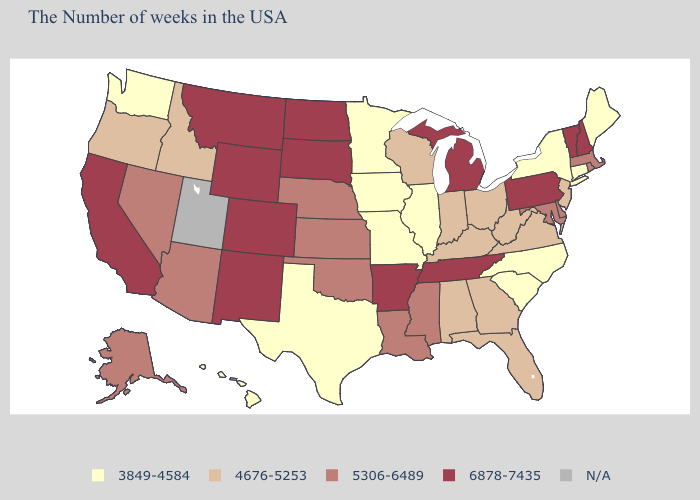How many symbols are there in the legend?
Concise answer only. 5. Among the states that border Texas , which have the lowest value?
Answer briefly. Louisiana, Oklahoma. What is the value of Missouri?
Quick response, please. 3849-4584. Does the map have missing data?
Answer briefly. Yes. Which states have the highest value in the USA?
Answer briefly. New Hampshire, Vermont, Pennsylvania, Michigan, Tennessee, Arkansas, South Dakota, North Dakota, Wyoming, Colorado, New Mexico, Montana, California. Which states have the lowest value in the South?
Short answer required. North Carolina, South Carolina, Texas. Among the states that border Rhode Island , does Massachusetts have the lowest value?
Short answer required. No. Name the states that have a value in the range 5306-6489?
Keep it brief. Massachusetts, Rhode Island, Delaware, Maryland, Mississippi, Louisiana, Kansas, Nebraska, Oklahoma, Arizona, Nevada, Alaska. What is the lowest value in the Northeast?
Quick response, please. 3849-4584. Which states hav the highest value in the West?
Answer briefly. Wyoming, Colorado, New Mexico, Montana, California. Which states have the lowest value in the Northeast?
Be succinct. Maine, Connecticut, New York. What is the value of Alaska?
Concise answer only. 5306-6489. 